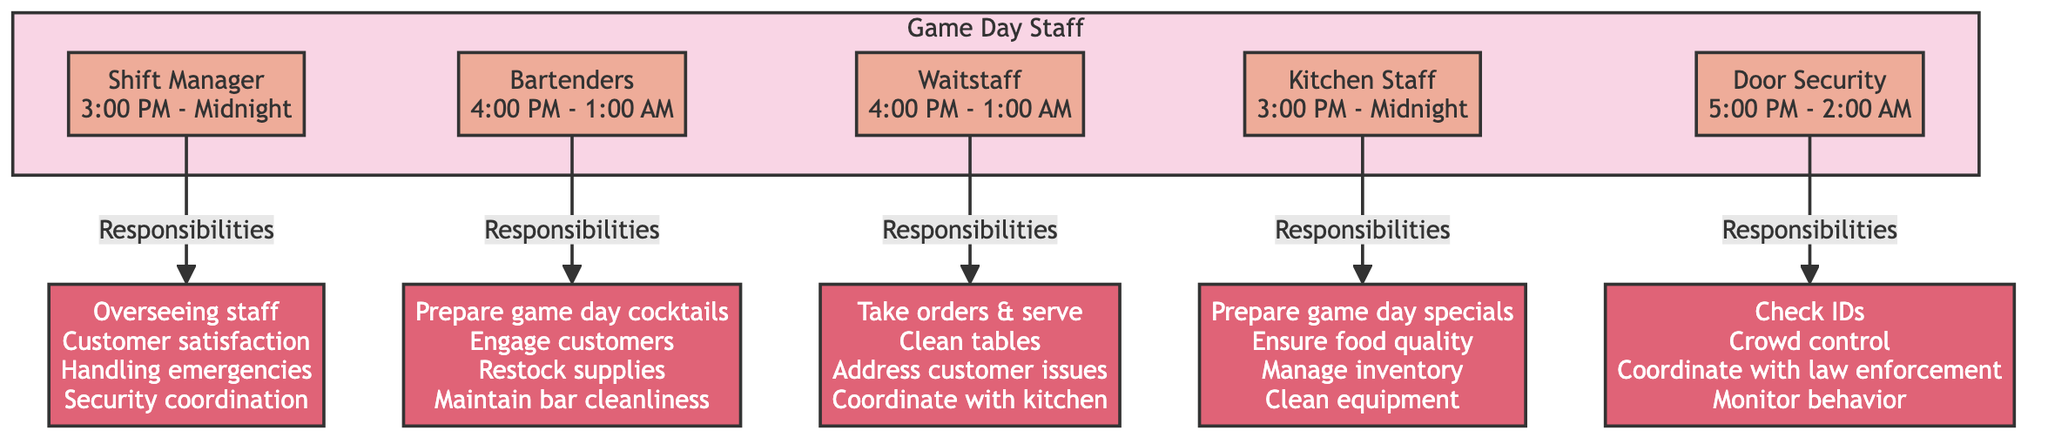What's the shift time for the Bartenders? The shift time for the Bartenders is specified directly in the diagram as "4:00 PM - 1:00 AM." This is found by looking at the node labeled "Bartenders."
Answer: 4:00 PM - 1:00 AM How many responsibilities does the Shift Manager have? The Shift Manager's responsibilities are detailed in the diagram, which lists four separate tasks: overseeing staff, ensuring customer satisfaction, handling emergencies, and coordinating security. Therefore, by counting these listed responsibilities, we determine that there are four.
Answer: 4 Which staff role has the latest shift ending time? The ending time of each role's shift is provided: the Shift Manager and Kitchen Staff finish at midnight, while the Bartenders finish at 1:00 AM, and the Door Security finishes at 2:00 AM. Comparing these times reveals that the Door Security has the latest shift ending time.
Answer: Door Security What is one responsibility of the Kitchen Staff? The diagram includes several listed responsibilities for the Kitchen Staff such as preparing game day specials, ensuring food quality, managing inventory, and cleaning equipment. Therefore, mentioning just one of these, like preparing game day specials, satisfies the question.
Answer: Preparing game day specials How does the Waitstaff coordinate with another role? The Waitstaff coordinates with the kitchen for timely service, as indicated in their responsibilities. This shows a clear interaction between the Waitstaff and Kitchen Staff roles in providing a seamless experience for customers on game day.
Answer: Kitchen Staff 